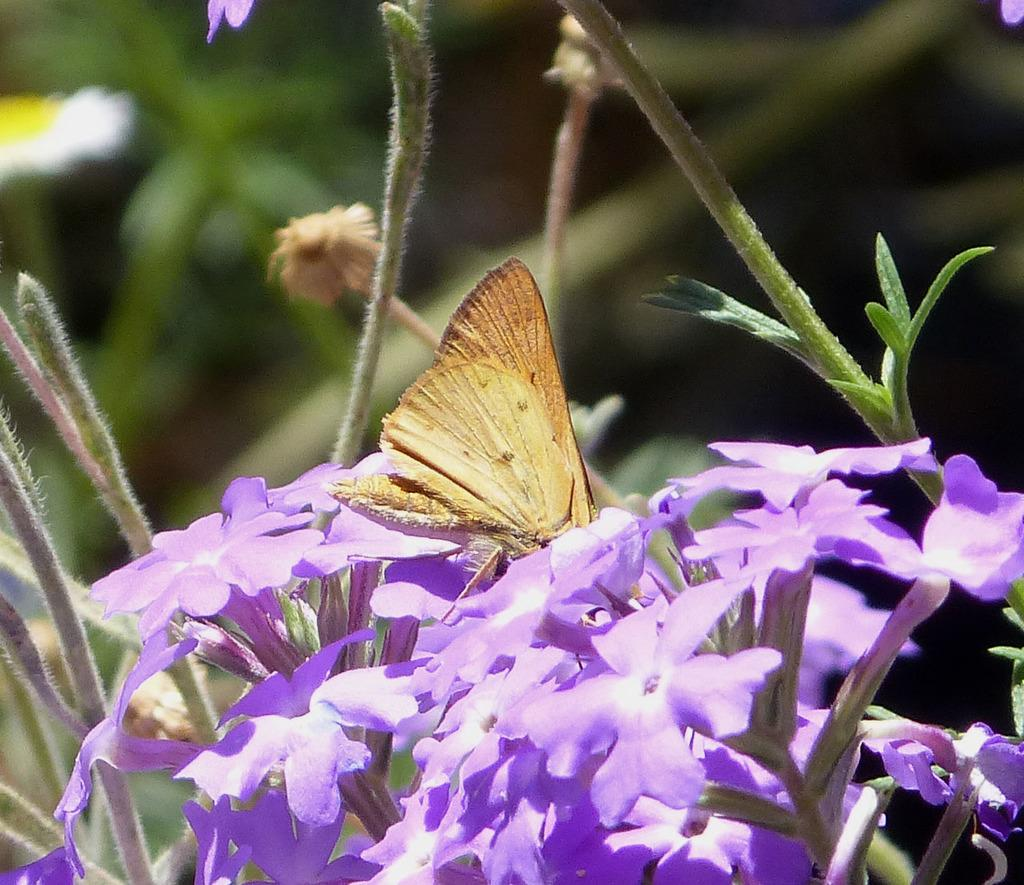What is the main subject of the image? The main subject of the image is a butterfly. Where is the butterfly located in the image? The butterfly is on lavender flowers. How many friends are with the butterfly on the cake in the image? There is no cake present in the image, and the butterfly is on lavender flowers, not with any friends. 